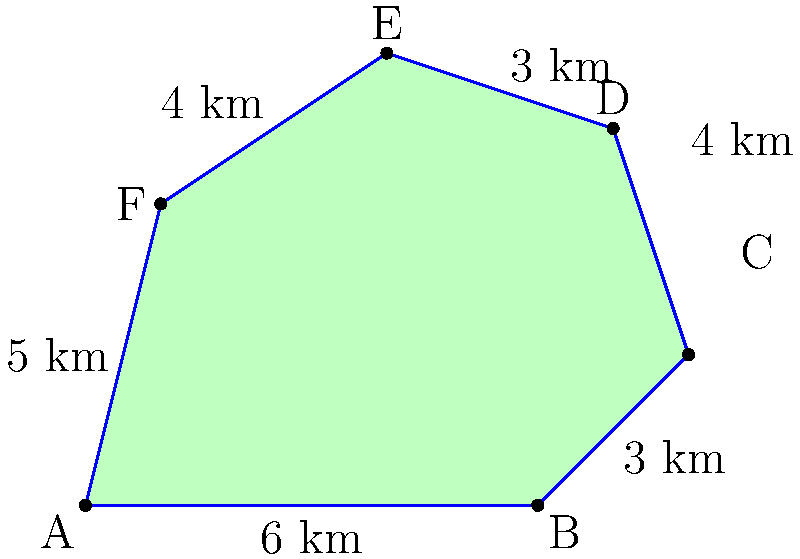As part of your clean air initiative, you're assessing the impact of pollution on a local lake. The lake's shape is represented by the irregular polygon shown above. If each grid square represents 1 square kilometer, what is the approximate area of the lake in square kilometers? Use the shoelace formula to calculate the exact area. To solve this problem, we'll use the shoelace formula, which is ideal for calculating the area of irregular polygons. The steps are as follows:

1) First, let's assign coordinates to each vertex:
   A(0,0), B(6,0), C(8,2), D(7,5), E(4,6), F(1,4)

2) The shoelace formula is:
   $$Area = \frac{1}{2}|(x_1y_2 + x_2y_3 + ... + x_ny_1) - (y_1x_2 + y_2x_3 + ... + y_nx_1)|$$

3) Let's plug in our coordinates:
   $$\begin{align*}
   Area &= \frac{1}{2}|[(0 \cdot 0) + (6 \cdot 2) + (8 \cdot 5) + (7 \cdot 6) + (4 \cdot 4) + (1 \cdot 0)]\\
   &- [(0 \cdot 6) + (0 \cdot 8) + (2 \cdot 7) + (5 \cdot 4) + (6 \cdot 1) + (4 \cdot 0)]|
   \end{align*}$$

4) Simplify:
   $$\begin{align*}
   Area &= \frac{1}{2}|[0 + 12 + 40 + 42 + 16 + 0] - [0 + 0 + 14 + 20 + 6 + 0]|\\
   &= \frac{1}{2}|110 - 40|\\
   &= \frac{1}{2} \cdot 70\\
   &= 35
   \end{align*}$$

Therefore, the exact area of the lake is 35 square kilometers.
Answer: 35 sq km 